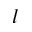Convert formula to latex. <formula><loc_0><loc_0><loc_500><loc_500>l</formula> 